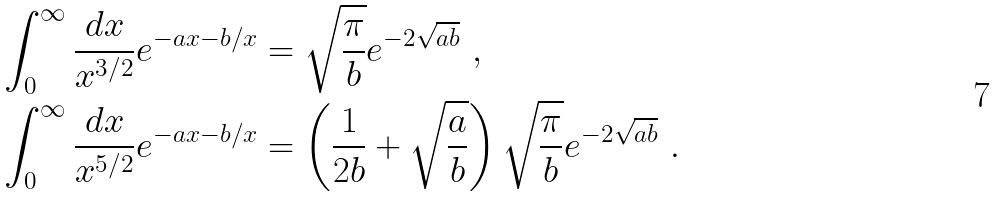<formula> <loc_0><loc_0><loc_500><loc_500>& \int _ { 0 } ^ { \infty } \frac { d x } { x ^ { 3 / 2 } } e ^ { - a x - b / x } = \sqrt { \frac { \pi } { b } } e ^ { - 2 \sqrt { a b } } \ , \\ & \int _ { 0 } ^ { \infty } \frac { d x } { x ^ { 5 / 2 } } e ^ { - a x - b / x } = \left ( \frac { 1 } { 2 b } + \sqrt { \frac { a } { b } } \right ) \sqrt { \frac { \pi } { b } } e ^ { - 2 \sqrt { a b } } \ .</formula> 